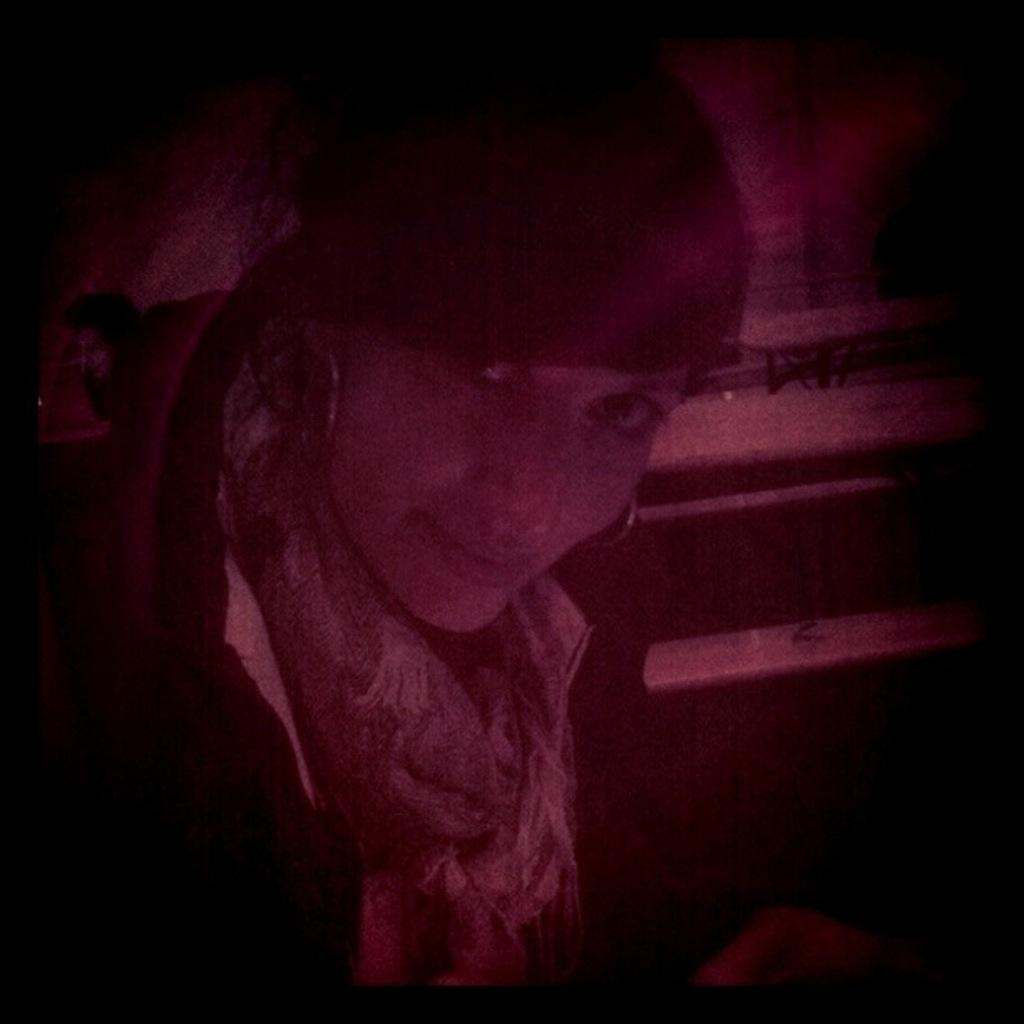What is the overall tone or lighting of the image? The image is dark. Who is present in the image? There is a woman in the image. What is the woman doing in the image? The woman is looking at a picture. What color is the background of the image? The background of the image is black. What type of friction can be seen between the woman and the rat in the image? There is no rat present in the image, so there is no friction between the woman and a rat. 